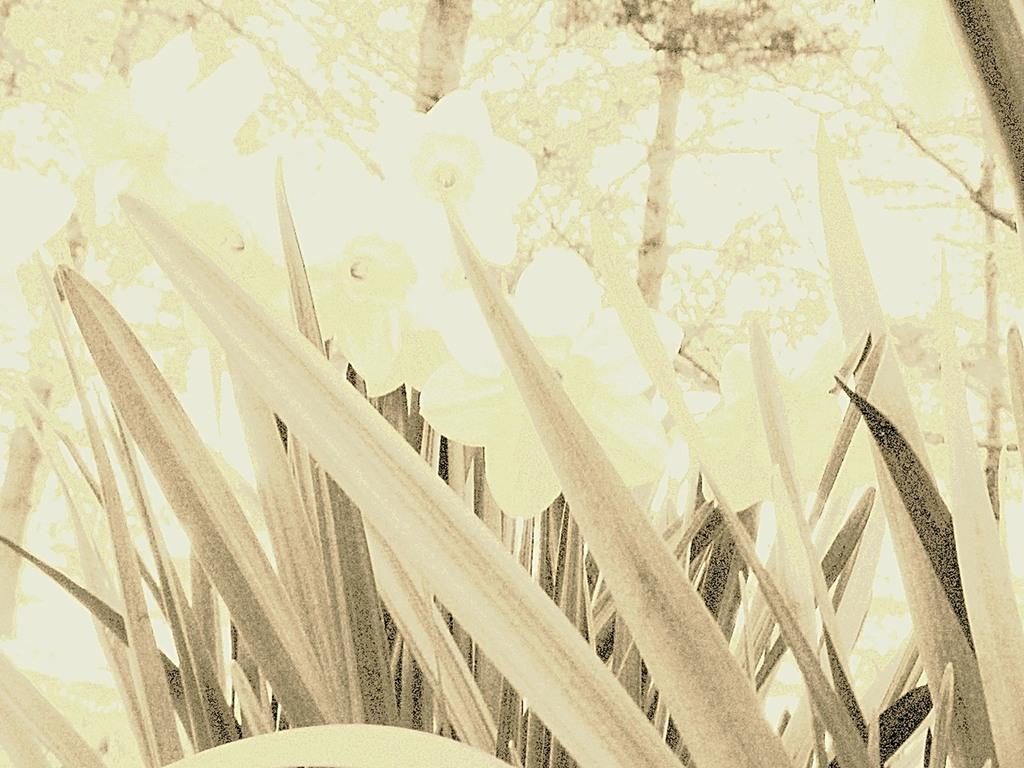Please provide a concise description of this image. In this image I can see trees and grass. 